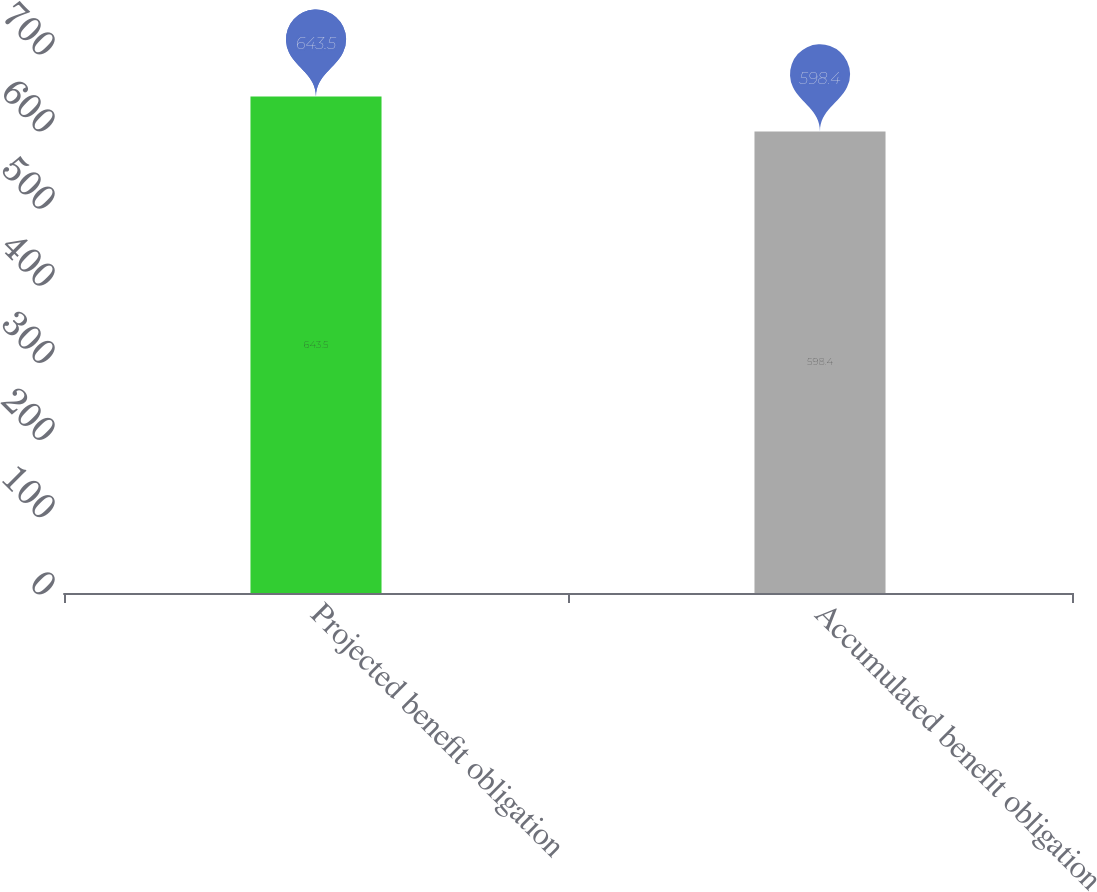<chart> <loc_0><loc_0><loc_500><loc_500><bar_chart><fcel>Projected benefit obligation<fcel>Accumulated benefit obligation<nl><fcel>643.5<fcel>598.4<nl></chart> 